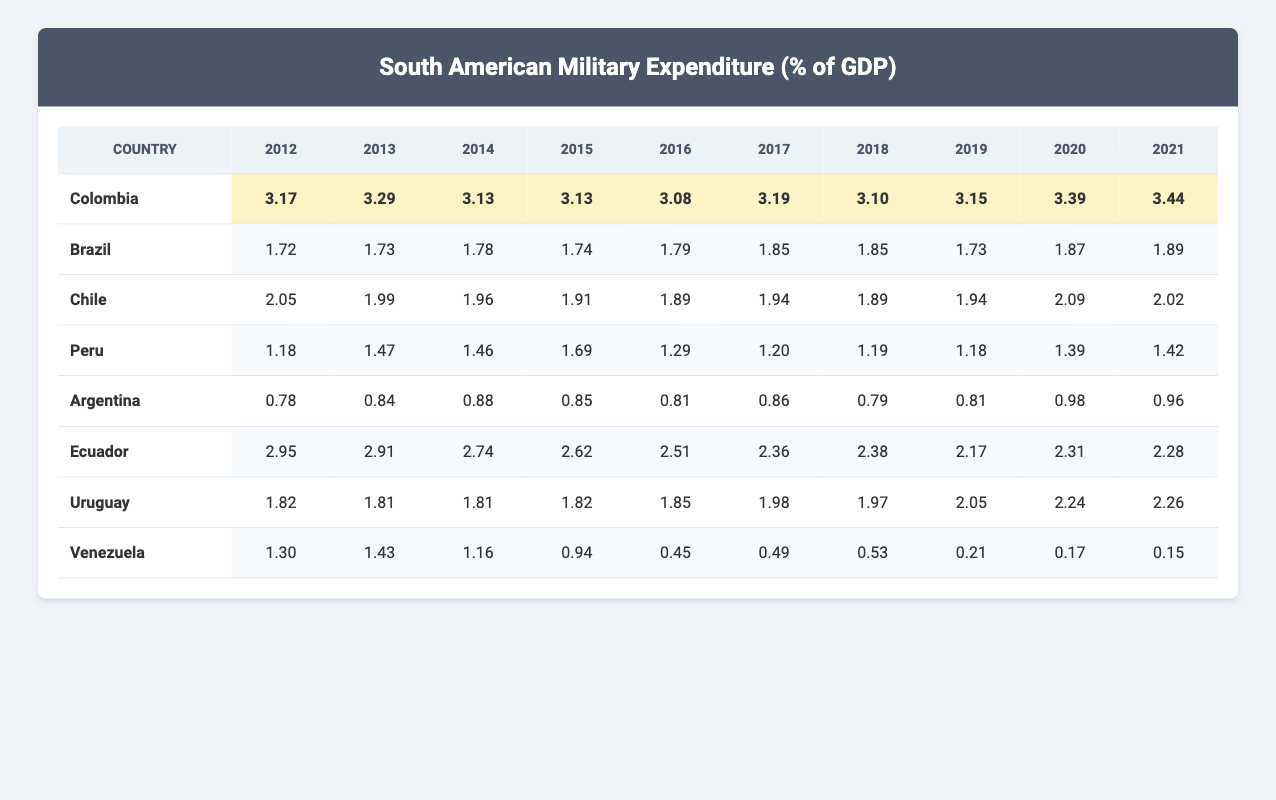What was Colombia's military expenditure as a percentage of GDP in 2021? According to the table, Colombia's military expenditure percentage for the year 2021 is listed as 3.44.
Answer: 3.44 Which country had the highest military expenditure as a percentage of GDP in 2016? By examining the table, in 2016, Colombia had the highest military expenditure at 3.08, while the next highest was Ecuador at 2.51.
Answer: Colombia What is the average military expenditure as a percentage of GDP for Brazil over the decade? To find the average, sum the values for Brazil from 2012 to 2021: (1.72 + 1.73 + 1.78 + 1.74 + 1.79 + 1.85 + 1.85 + 1.73 + 1.87 + 1.89) = 17.74, and then divide by the number of years (10), giving an average of 1.774.
Answer: 1.77 Did Argentina's military expenditure percentage increase or decrease from 2012 to 2021? Looking at the values for Argentina, it shows an increase from 0.78 in 2012 to 0.96 in 2021. Therefore, Argentina's military expenditure percentage increased over this period.
Answer: Increase In which year did Venezuela have its lowest military expenditure as a percentage of GDP? The table shows that Venezuela's lowest military expenditure percentage was in 2021, where it is reported as 0.15, the lowest figure among all years listed.
Answer: 2021 How much higher was Colombia's military expenditure than that of Venezuela in 2019? In 2019, Colombia's expenditure was 3.15 and Venezuela's was 0.21. The difference is calculated as (3.15 - 0.21) = 2.94.
Answer: 2.94 Is it true that Chile had a military expenditure percentage above 2.0 in 2020? Checking the values, Chile’s military expenditure in 2020 was 2.09, which is indeed above 2.0. Therefore, the statement is true.
Answer: True What is the trend in military expenditure as a percentage of GDP for Ecuador from 2012 to 2021? The values for Ecuador show a decreasing trend from 2.95 in 2012 down to 2.28 in 2021, indicating a consistent decline over the decade.
Answer: Decreasing 